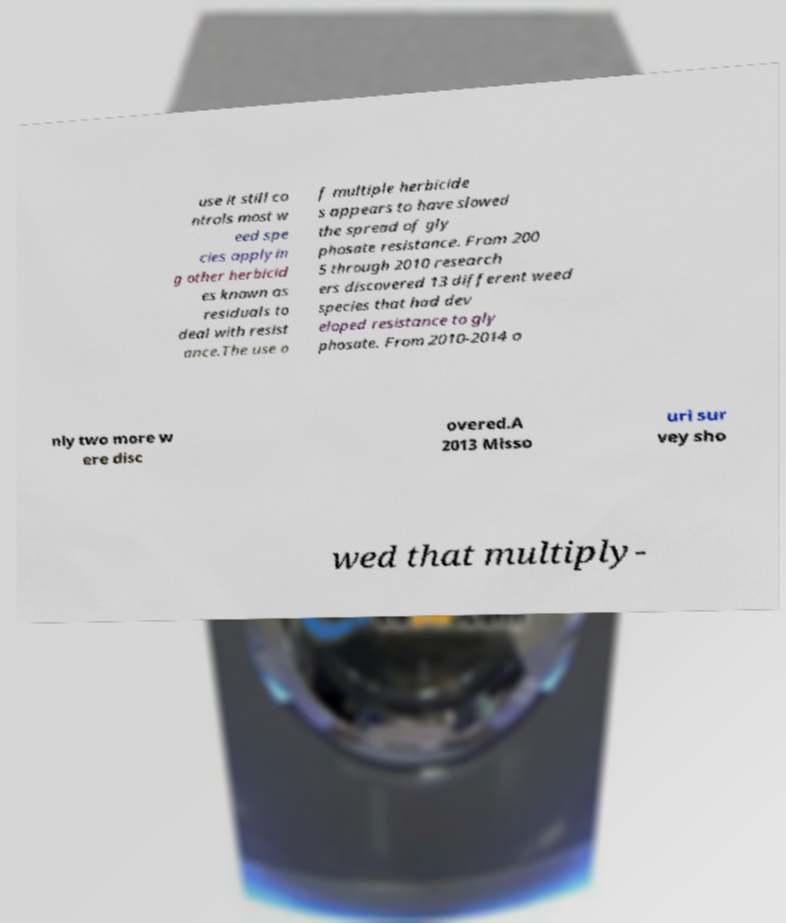I need the written content from this picture converted into text. Can you do that? use it still co ntrols most w eed spe cies applyin g other herbicid es known as residuals to deal with resist ance.The use o f multiple herbicide s appears to have slowed the spread of gly phosate resistance. From 200 5 through 2010 research ers discovered 13 different weed species that had dev eloped resistance to gly phosate. From 2010-2014 o nly two more w ere disc overed.A 2013 Misso uri sur vey sho wed that multiply- 